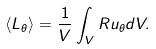<formula> <loc_0><loc_0><loc_500><loc_500>\left < L _ { \theta } \right > = \frac { 1 } { V } \int _ { V } R u _ { \theta } d V .</formula> 